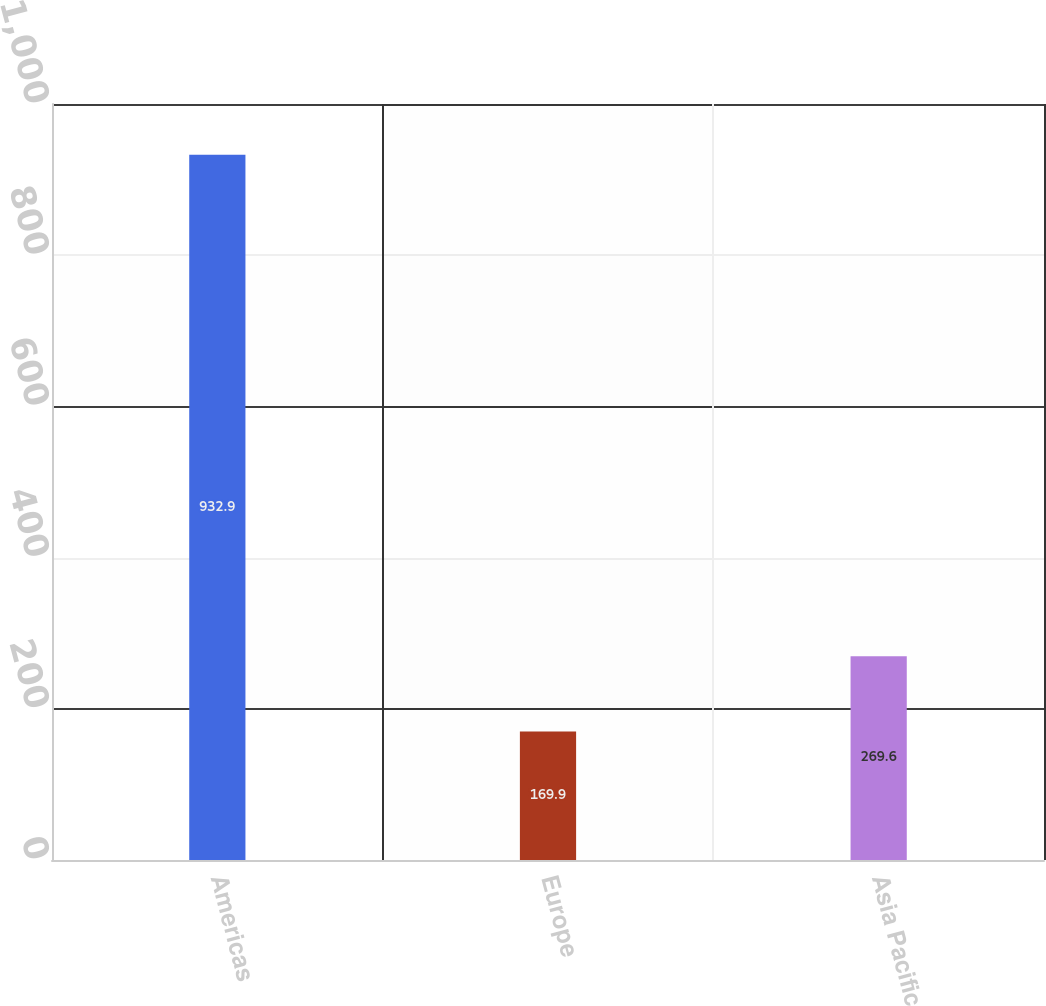Convert chart to OTSL. <chart><loc_0><loc_0><loc_500><loc_500><bar_chart><fcel>Americas<fcel>Europe<fcel>Asia Pacific<nl><fcel>932.9<fcel>169.9<fcel>269.6<nl></chart> 